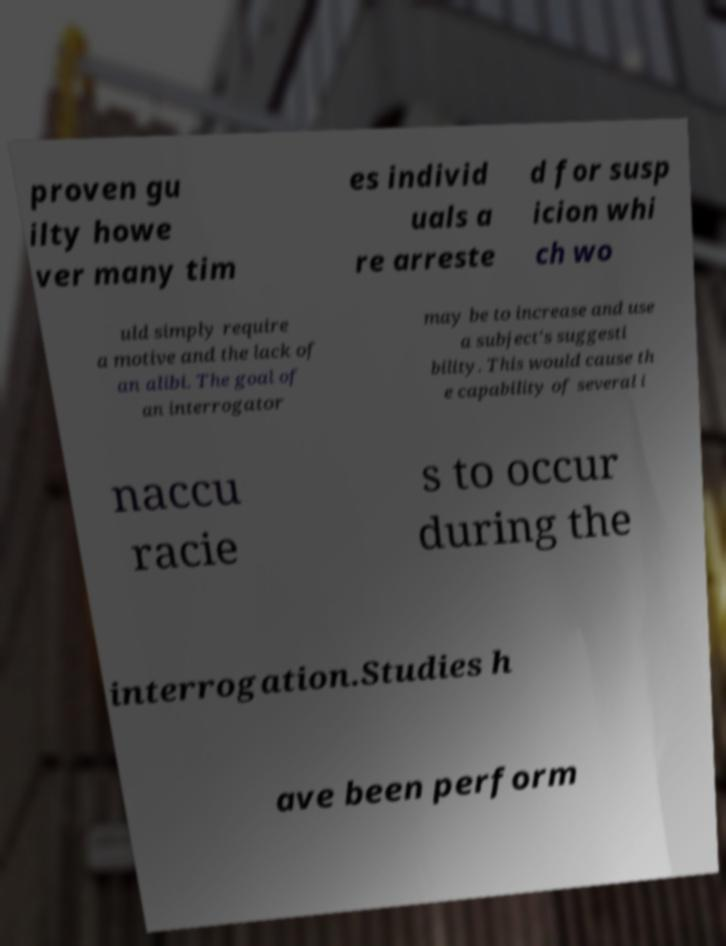Please read and relay the text visible in this image. What does it say? proven gu ilty howe ver many tim es individ uals a re arreste d for susp icion whi ch wo uld simply require a motive and the lack of an alibi. The goal of an interrogator may be to increase and use a subject's suggesti bility. This would cause th e capability of several i naccu racie s to occur during the interrogation.Studies h ave been perform 